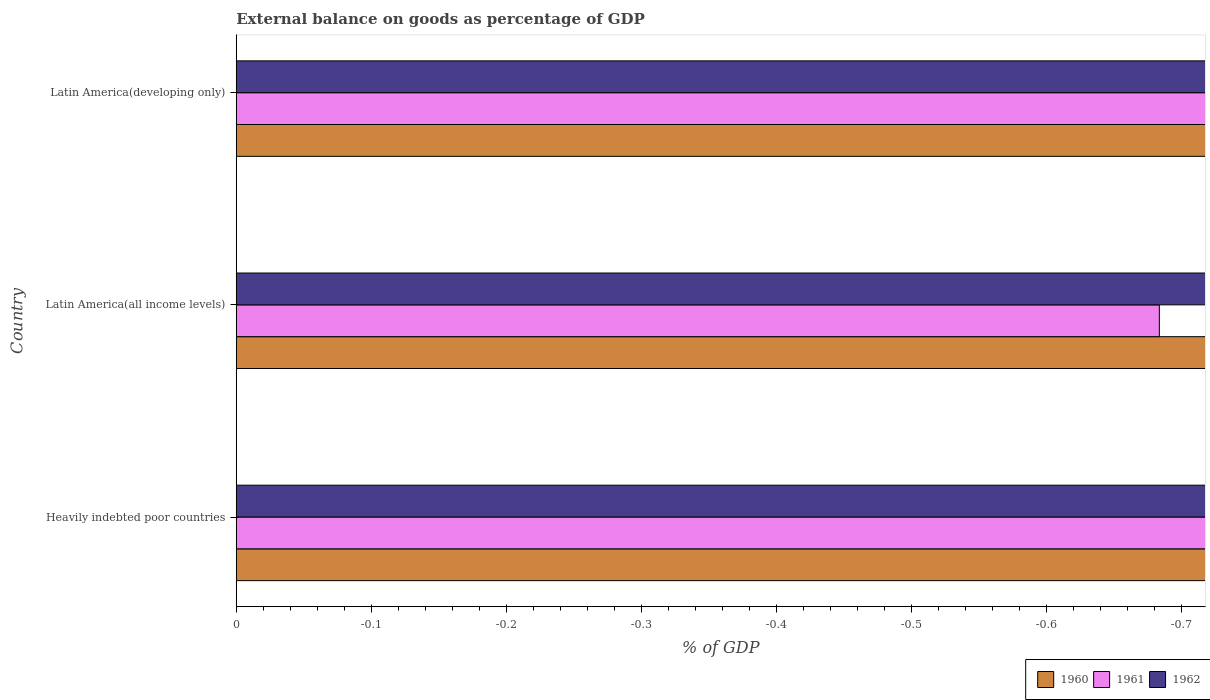How many different coloured bars are there?
Keep it short and to the point. 0. How many bars are there on the 3rd tick from the top?
Offer a very short reply. 0. What is the label of the 1st group of bars from the top?
Make the answer very short. Latin America(developing only). What is the external balance on goods as percentage of GDP in 1960 in Latin America(developing only)?
Your answer should be compact. 0. What is the difference between the external balance on goods as percentage of GDP in 1961 in Heavily indebted poor countries and the external balance on goods as percentage of GDP in 1960 in Latin America(all income levels)?
Make the answer very short. 0. What is the average external balance on goods as percentage of GDP in 1961 per country?
Ensure brevity in your answer.  0. In how many countries, is the external balance on goods as percentage of GDP in 1960 greater than the average external balance on goods as percentage of GDP in 1960 taken over all countries?
Your response must be concise. 0. Are all the bars in the graph horizontal?
Offer a terse response. Yes. What is the difference between two consecutive major ticks on the X-axis?
Give a very brief answer. 0.1. Does the graph contain any zero values?
Make the answer very short. Yes. How many legend labels are there?
Offer a terse response. 3. What is the title of the graph?
Ensure brevity in your answer.  External balance on goods as percentage of GDP. Does "1981" appear as one of the legend labels in the graph?
Your answer should be compact. No. What is the label or title of the X-axis?
Provide a short and direct response. % of GDP. What is the label or title of the Y-axis?
Ensure brevity in your answer.  Country. What is the % of GDP of 1962 in Latin America(all income levels)?
Your response must be concise. 0. What is the total % of GDP in 1962 in the graph?
Your response must be concise. 0. What is the average % of GDP of 1961 per country?
Give a very brief answer. 0. 